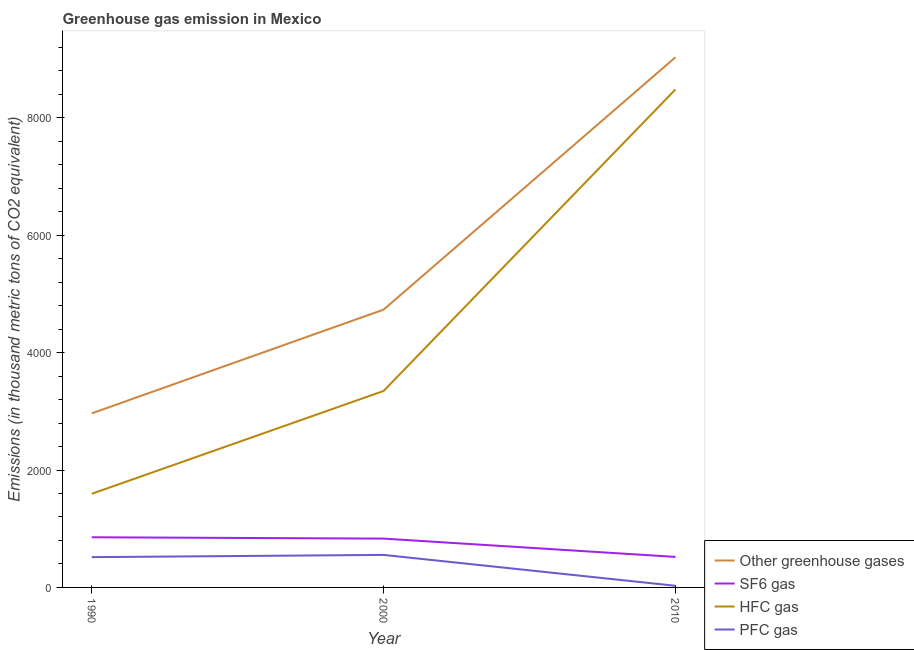How many different coloured lines are there?
Ensure brevity in your answer.  4. Does the line corresponding to emission of greenhouse gases intersect with the line corresponding to emission of pfc gas?
Your answer should be compact. No. What is the emission of greenhouse gases in 2010?
Ensure brevity in your answer.  9033. Across all years, what is the maximum emission of greenhouse gases?
Your answer should be compact. 9033. Across all years, what is the minimum emission of greenhouse gases?
Keep it short and to the point. 2965.8. In which year was the emission of greenhouse gases maximum?
Ensure brevity in your answer.  2010. In which year was the emission of sf6 gas minimum?
Provide a short and direct response. 2010. What is the total emission of sf6 gas in the graph?
Give a very brief answer. 2206.3. What is the difference between the emission of hfc gas in 1990 and that in 2000?
Provide a succinct answer. -1752. What is the difference between the emission of sf6 gas in 2000 and the emission of pfc gas in 2010?
Keep it short and to the point. 803.8. What is the average emission of greenhouse gases per year?
Your answer should be compact. 5577.33. In the year 1990, what is the difference between the emission of greenhouse gases and emission of sf6 gas?
Make the answer very short. 2111.3. What is the ratio of the emission of greenhouse gases in 2000 to that in 2010?
Offer a terse response. 0.52. What is the difference between the highest and the second highest emission of pfc gas?
Offer a very short reply. 38.1. What is the difference between the highest and the lowest emission of hfc gas?
Keep it short and to the point. 6889.7. In how many years, is the emission of sf6 gas greater than the average emission of sf6 gas taken over all years?
Keep it short and to the point. 2. Is the sum of the emission of pfc gas in 1990 and 2000 greater than the maximum emission of greenhouse gases across all years?
Provide a short and direct response. No. Is it the case that in every year, the sum of the emission of greenhouse gases and emission of sf6 gas is greater than the sum of emission of pfc gas and emission of hfc gas?
Give a very brief answer. No. Does the emission of hfc gas monotonically increase over the years?
Give a very brief answer. Yes. How many lines are there?
Ensure brevity in your answer.  4. How many years are there in the graph?
Provide a short and direct response. 3. What is the difference between two consecutive major ticks on the Y-axis?
Your response must be concise. 2000. Does the graph contain grids?
Offer a very short reply. No. Where does the legend appear in the graph?
Make the answer very short. Bottom right. What is the title of the graph?
Your answer should be very brief. Greenhouse gas emission in Mexico. Does "Self-employed" appear as one of the legend labels in the graph?
Your answer should be very brief. No. What is the label or title of the Y-axis?
Your answer should be very brief. Emissions (in thousand metric tons of CO2 equivalent). What is the Emissions (in thousand metric tons of CO2 equivalent) in Other greenhouse gases in 1990?
Provide a succinct answer. 2965.8. What is the Emissions (in thousand metric tons of CO2 equivalent) in SF6 gas in 1990?
Your answer should be compact. 854.5. What is the Emissions (in thousand metric tons of CO2 equivalent) of HFC gas in 1990?
Keep it short and to the point. 1595.3. What is the Emissions (in thousand metric tons of CO2 equivalent) in PFC gas in 1990?
Provide a short and direct response. 516. What is the Emissions (in thousand metric tons of CO2 equivalent) in Other greenhouse gases in 2000?
Provide a succinct answer. 4733.2. What is the Emissions (in thousand metric tons of CO2 equivalent) of SF6 gas in 2000?
Your answer should be compact. 831.8. What is the Emissions (in thousand metric tons of CO2 equivalent) of HFC gas in 2000?
Offer a very short reply. 3347.3. What is the Emissions (in thousand metric tons of CO2 equivalent) of PFC gas in 2000?
Give a very brief answer. 554.1. What is the Emissions (in thousand metric tons of CO2 equivalent) of Other greenhouse gases in 2010?
Make the answer very short. 9033. What is the Emissions (in thousand metric tons of CO2 equivalent) of SF6 gas in 2010?
Keep it short and to the point. 520. What is the Emissions (in thousand metric tons of CO2 equivalent) in HFC gas in 2010?
Offer a very short reply. 8485. What is the Emissions (in thousand metric tons of CO2 equivalent) of PFC gas in 2010?
Offer a terse response. 28. Across all years, what is the maximum Emissions (in thousand metric tons of CO2 equivalent) in Other greenhouse gases?
Give a very brief answer. 9033. Across all years, what is the maximum Emissions (in thousand metric tons of CO2 equivalent) of SF6 gas?
Provide a short and direct response. 854.5. Across all years, what is the maximum Emissions (in thousand metric tons of CO2 equivalent) in HFC gas?
Your answer should be very brief. 8485. Across all years, what is the maximum Emissions (in thousand metric tons of CO2 equivalent) in PFC gas?
Your answer should be compact. 554.1. Across all years, what is the minimum Emissions (in thousand metric tons of CO2 equivalent) in Other greenhouse gases?
Your answer should be compact. 2965.8. Across all years, what is the minimum Emissions (in thousand metric tons of CO2 equivalent) of SF6 gas?
Your answer should be compact. 520. Across all years, what is the minimum Emissions (in thousand metric tons of CO2 equivalent) of HFC gas?
Make the answer very short. 1595.3. Across all years, what is the minimum Emissions (in thousand metric tons of CO2 equivalent) of PFC gas?
Provide a short and direct response. 28. What is the total Emissions (in thousand metric tons of CO2 equivalent) of Other greenhouse gases in the graph?
Your answer should be very brief. 1.67e+04. What is the total Emissions (in thousand metric tons of CO2 equivalent) of SF6 gas in the graph?
Give a very brief answer. 2206.3. What is the total Emissions (in thousand metric tons of CO2 equivalent) of HFC gas in the graph?
Your answer should be compact. 1.34e+04. What is the total Emissions (in thousand metric tons of CO2 equivalent) in PFC gas in the graph?
Offer a very short reply. 1098.1. What is the difference between the Emissions (in thousand metric tons of CO2 equivalent) in Other greenhouse gases in 1990 and that in 2000?
Give a very brief answer. -1767.4. What is the difference between the Emissions (in thousand metric tons of CO2 equivalent) of SF6 gas in 1990 and that in 2000?
Keep it short and to the point. 22.7. What is the difference between the Emissions (in thousand metric tons of CO2 equivalent) in HFC gas in 1990 and that in 2000?
Give a very brief answer. -1752. What is the difference between the Emissions (in thousand metric tons of CO2 equivalent) in PFC gas in 1990 and that in 2000?
Make the answer very short. -38.1. What is the difference between the Emissions (in thousand metric tons of CO2 equivalent) in Other greenhouse gases in 1990 and that in 2010?
Keep it short and to the point. -6067.2. What is the difference between the Emissions (in thousand metric tons of CO2 equivalent) of SF6 gas in 1990 and that in 2010?
Provide a succinct answer. 334.5. What is the difference between the Emissions (in thousand metric tons of CO2 equivalent) in HFC gas in 1990 and that in 2010?
Your answer should be very brief. -6889.7. What is the difference between the Emissions (in thousand metric tons of CO2 equivalent) of PFC gas in 1990 and that in 2010?
Keep it short and to the point. 488. What is the difference between the Emissions (in thousand metric tons of CO2 equivalent) in Other greenhouse gases in 2000 and that in 2010?
Your answer should be very brief. -4299.8. What is the difference between the Emissions (in thousand metric tons of CO2 equivalent) in SF6 gas in 2000 and that in 2010?
Your response must be concise. 311.8. What is the difference between the Emissions (in thousand metric tons of CO2 equivalent) of HFC gas in 2000 and that in 2010?
Provide a short and direct response. -5137.7. What is the difference between the Emissions (in thousand metric tons of CO2 equivalent) in PFC gas in 2000 and that in 2010?
Keep it short and to the point. 526.1. What is the difference between the Emissions (in thousand metric tons of CO2 equivalent) of Other greenhouse gases in 1990 and the Emissions (in thousand metric tons of CO2 equivalent) of SF6 gas in 2000?
Your answer should be compact. 2134. What is the difference between the Emissions (in thousand metric tons of CO2 equivalent) in Other greenhouse gases in 1990 and the Emissions (in thousand metric tons of CO2 equivalent) in HFC gas in 2000?
Ensure brevity in your answer.  -381.5. What is the difference between the Emissions (in thousand metric tons of CO2 equivalent) in Other greenhouse gases in 1990 and the Emissions (in thousand metric tons of CO2 equivalent) in PFC gas in 2000?
Keep it short and to the point. 2411.7. What is the difference between the Emissions (in thousand metric tons of CO2 equivalent) of SF6 gas in 1990 and the Emissions (in thousand metric tons of CO2 equivalent) of HFC gas in 2000?
Your response must be concise. -2492.8. What is the difference between the Emissions (in thousand metric tons of CO2 equivalent) of SF6 gas in 1990 and the Emissions (in thousand metric tons of CO2 equivalent) of PFC gas in 2000?
Keep it short and to the point. 300.4. What is the difference between the Emissions (in thousand metric tons of CO2 equivalent) of HFC gas in 1990 and the Emissions (in thousand metric tons of CO2 equivalent) of PFC gas in 2000?
Your response must be concise. 1041.2. What is the difference between the Emissions (in thousand metric tons of CO2 equivalent) in Other greenhouse gases in 1990 and the Emissions (in thousand metric tons of CO2 equivalent) in SF6 gas in 2010?
Ensure brevity in your answer.  2445.8. What is the difference between the Emissions (in thousand metric tons of CO2 equivalent) of Other greenhouse gases in 1990 and the Emissions (in thousand metric tons of CO2 equivalent) of HFC gas in 2010?
Your response must be concise. -5519.2. What is the difference between the Emissions (in thousand metric tons of CO2 equivalent) of Other greenhouse gases in 1990 and the Emissions (in thousand metric tons of CO2 equivalent) of PFC gas in 2010?
Ensure brevity in your answer.  2937.8. What is the difference between the Emissions (in thousand metric tons of CO2 equivalent) in SF6 gas in 1990 and the Emissions (in thousand metric tons of CO2 equivalent) in HFC gas in 2010?
Your answer should be very brief. -7630.5. What is the difference between the Emissions (in thousand metric tons of CO2 equivalent) of SF6 gas in 1990 and the Emissions (in thousand metric tons of CO2 equivalent) of PFC gas in 2010?
Keep it short and to the point. 826.5. What is the difference between the Emissions (in thousand metric tons of CO2 equivalent) of HFC gas in 1990 and the Emissions (in thousand metric tons of CO2 equivalent) of PFC gas in 2010?
Your answer should be compact. 1567.3. What is the difference between the Emissions (in thousand metric tons of CO2 equivalent) of Other greenhouse gases in 2000 and the Emissions (in thousand metric tons of CO2 equivalent) of SF6 gas in 2010?
Provide a short and direct response. 4213.2. What is the difference between the Emissions (in thousand metric tons of CO2 equivalent) of Other greenhouse gases in 2000 and the Emissions (in thousand metric tons of CO2 equivalent) of HFC gas in 2010?
Your answer should be compact. -3751.8. What is the difference between the Emissions (in thousand metric tons of CO2 equivalent) of Other greenhouse gases in 2000 and the Emissions (in thousand metric tons of CO2 equivalent) of PFC gas in 2010?
Your answer should be very brief. 4705.2. What is the difference between the Emissions (in thousand metric tons of CO2 equivalent) in SF6 gas in 2000 and the Emissions (in thousand metric tons of CO2 equivalent) in HFC gas in 2010?
Keep it short and to the point. -7653.2. What is the difference between the Emissions (in thousand metric tons of CO2 equivalent) in SF6 gas in 2000 and the Emissions (in thousand metric tons of CO2 equivalent) in PFC gas in 2010?
Provide a short and direct response. 803.8. What is the difference between the Emissions (in thousand metric tons of CO2 equivalent) in HFC gas in 2000 and the Emissions (in thousand metric tons of CO2 equivalent) in PFC gas in 2010?
Your answer should be very brief. 3319.3. What is the average Emissions (in thousand metric tons of CO2 equivalent) of Other greenhouse gases per year?
Provide a short and direct response. 5577.33. What is the average Emissions (in thousand metric tons of CO2 equivalent) of SF6 gas per year?
Provide a succinct answer. 735.43. What is the average Emissions (in thousand metric tons of CO2 equivalent) in HFC gas per year?
Provide a succinct answer. 4475.87. What is the average Emissions (in thousand metric tons of CO2 equivalent) in PFC gas per year?
Provide a short and direct response. 366.03. In the year 1990, what is the difference between the Emissions (in thousand metric tons of CO2 equivalent) in Other greenhouse gases and Emissions (in thousand metric tons of CO2 equivalent) in SF6 gas?
Keep it short and to the point. 2111.3. In the year 1990, what is the difference between the Emissions (in thousand metric tons of CO2 equivalent) of Other greenhouse gases and Emissions (in thousand metric tons of CO2 equivalent) of HFC gas?
Provide a short and direct response. 1370.5. In the year 1990, what is the difference between the Emissions (in thousand metric tons of CO2 equivalent) in Other greenhouse gases and Emissions (in thousand metric tons of CO2 equivalent) in PFC gas?
Make the answer very short. 2449.8. In the year 1990, what is the difference between the Emissions (in thousand metric tons of CO2 equivalent) of SF6 gas and Emissions (in thousand metric tons of CO2 equivalent) of HFC gas?
Ensure brevity in your answer.  -740.8. In the year 1990, what is the difference between the Emissions (in thousand metric tons of CO2 equivalent) in SF6 gas and Emissions (in thousand metric tons of CO2 equivalent) in PFC gas?
Make the answer very short. 338.5. In the year 1990, what is the difference between the Emissions (in thousand metric tons of CO2 equivalent) of HFC gas and Emissions (in thousand metric tons of CO2 equivalent) of PFC gas?
Provide a succinct answer. 1079.3. In the year 2000, what is the difference between the Emissions (in thousand metric tons of CO2 equivalent) of Other greenhouse gases and Emissions (in thousand metric tons of CO2 equivalent) of SF6 gas?
Give a very brief answer. 3901.4. In the year 2000, what is the difference between the Emissions (in thousand metric tons of CO2 equivalent) of Other greenhouse gases and Emissions (in thousand metric tons of CO2 equivalent) of HFC gas?
Provide a short and direct response. 1385.9. In the year 2000, what is the difference between the Emissions (in thousand metric tons of CO2 equivalent) in Other greenhouse gases and Emissions (in thousand metric tons of CO2 equivalent) in PFC gas?
Give a very brief answer. 4179.1. In the year 2000, what is the difference between the Emissions (in thousand metric tons of CO2 equivalent) of SF6 gas and Emissions (in thousand metric tons of CO2 equivalent) of HFC gas?
Ensure brevity in your answer.  -2515.5. In the year 2000, what is the difference between the Emissions (in thousand metric tons of CO2 equivalent) in SF6 gas and Emissions (in thousand metric tons of CO2 equivalent) in PFC gas?
Provide a succinct answer. 277.7. In the year 2000, what is the difference between the Emissions (in thousand metric tons of CO2 equivalent) of HFC gas and Emissions (in thousand metric tons of CO2 equivalent) of PFC gas?
Keep it short and to the point. 2793.2. In the year 2010, what is the difference between the Emissions (in thousand metric tons of CO2 equivalent) in Other greenhouse gases and Emissions (in thousand metric tons of CO2 equivalent) in SF6 gas?
Make the answer very short. 8513. In the year 2010, what is the difference between the Emissions (in thousand metric tons of CO2 equivalent) of Other greenhouse gases and Emissions (in thousand metric tons of CO2 equivalent) of HFC gas?
Offer a very short reply. 548. In the year 2010, what is the difference between the Emissions (in thousand metric tons of CO2 equivalent) of Other greenhouse gases and Emissions (in thousand metric tons of CO2 equivalent) of PFC gas?
Make the answer very short. 9005. In the year 2010, what is the difference between the Emissions (in thousand metric tons of CO2 equivalent) of SF6 gas and Emissions (in thousand metric tons of CO2 equivalent) of HFC gas?
Offer a very short reply. -7965. In the year 2010, what is the difference between the Emissions (in thousand metric tons of CO2 equivalent) of SF6 gas and Emissions (in thousand metric tons of CO2 equivalent) of PFC gas?
Provide a short and direct response. 492. In the year 2010, what is the difference between the Emissions (in thousand metric tons of CO2 equivalent) of HFC gas and Emissions (in thousand metric tons of CO2 equivalent) of PFC gas?
Keep it short and to the point. 8457. What is the ratio of the Emissions (in thousand metric tons of CO2 equivalent) in Other greenhouse gases in 1990 to that in 2000?
Your response must be concise. 0.63. What is the ratio of the Emissions (in thousand metric tons of CO2 equivalent) in SF6 gas in 1990 to that in 2000?
Offer a very short reply. 1.03. What is the ratio of the Emissions (in thousand metric tons of CO2 equivalent) of HFC gas in 1990 to that in 2000?
Provide a short and direct response. 0.48. What is the ratio of the Emissions (in thousand metric tons of CO2 equivalent) of PFC gas in 1990 to that in 2000?
Keep it short and to the point. 0.93. What is the ratio of the Emissions (in thousand metric tons of CO2 equivalent) in Other greenhouse gases in 1990 to that in 2010?
Make the answer very short. 0.33. What is the ratio of the Emissions (in thousand metric tons of CO2 equivalent) of SF6 gas in 1990 to that in 2010?
Your answer should be very brief. 1.64. What is the ratio of the Emissions (in thousand metric tons of CO2 equivalent) of HFC gas in 1990 to that in 2010?
Give a very brief answer. 0.19. What is the ratio of the Emissions (in thousand metric tons of CO2 equivalent) in PFC gas in 1990 to that in 2010?
Your answer should be very brief. 18.43. What is the ratio of the Emissions (in thousand metric tons of CO2 equivalent) of Other greenhouse gases in 2000 to that in 2010?
Keep it short and to the point. 0.52. What is the ratio of the Emissions (in thousand metric tons of CO2 equivalent) in SF6 gas in 2000 to that in 2010?
Offer a very short reply. 1.6. What is the ratio of the Emissions (in thousand metric tons of CO2 equivalent) of HFC gas in 2000 to that in 2010?
Ensure brevity in your answer.  0.39. What is the ratio of the Emissions (in thousand metric tons of CO2 equivalent) of PFC gas in 2000 to that in 2010?
Your response must be concise. 19.79. What is the difference between the highest and the second highest Emissions (in thousand metric tons of CO2 equivalent) of Other greenhouse gases?
Offer a very short reply. 4299.8. What is the difference between the highest and the second highest Emissions (in thousand metric tons of CO2 equivalent) of SF6 gas?
Give a very brief answer. 22.7. What is the difference between the highest and the second highest Emissions (in thousand metric tons of CO2 equivalent) of HFC gas?
Offer a very short reply. 5137.7. What is the difference between the highest and the second highest Emissions (in thousand metric tons of CO2 equivalent) of PFC gas?
Offer a very short reply. 38.1. What is the difference between the highest and the lowest Emissions (in thousand metric tons of CO2 equivalent) of Other greenhouse gases?
Provide a short and direct response. 6067.2. What is the difference between the highest and the lowest Emissions (in thousand metric tons of CO2 equivalent) in SF6 gas?
Make the answer very short. 334.5. What is the difference between the highest and the lowest Emissions (in thousand metric tons of CO2 equivalent) of HFC gas?
Provide a short and direct response. 6889.7. What is the difference between the highest and the lowest Emissions (in thousand metric tons of CO2 equivalent) in PFC gas?
Your answer should be compact. 526.1. 